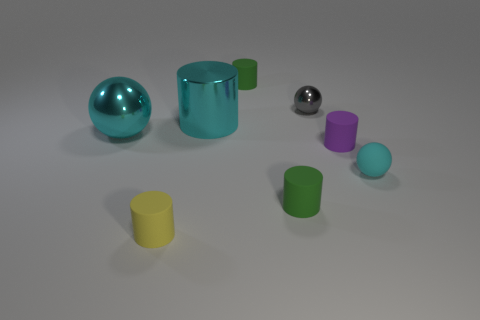What is the material of the cyan ball that is the same size as the yellow rubber object?
Provide a succinct answer. Rubber. There is a rubber object that is in front of the tiny green cylinder on the right side of the tiny green matte cylinder that is behind the small gray metal object; what size is it?
Ensure brevity in your answer.  Small. The cyan thing that is made of the same material as the yellow cylinder is what size?
Provide a succinct answer. Small. Does the cyan shiny sphere have the same size as the rubber cylinder behind the cyan shiny ball?
Offer a terse response. No. What shape is the matte object behind the tiny purple matte cylinder?
Offer a very short reply. Cylinder. There is a tiny cylinder on the left side of the cylinder behind the large metal cylinder; are there any small rubber objects that are in front of it?
Ensure brevity in your answer.  No. There is a small yellow object that is the same shape as the purple matte thing; what is it made of?
Keep it short and to the point. Rubber. Are there any other things that have the same material as the large cylinder?
Give a very brief answer. Yes. How many cylinders are large green things or purple things?
Keep it short and to the point. 1. Does the green thing behind the rubber sphere have the same size as the cyan sphere behind the small rubber ball?
Your answer should be very brief. No. 